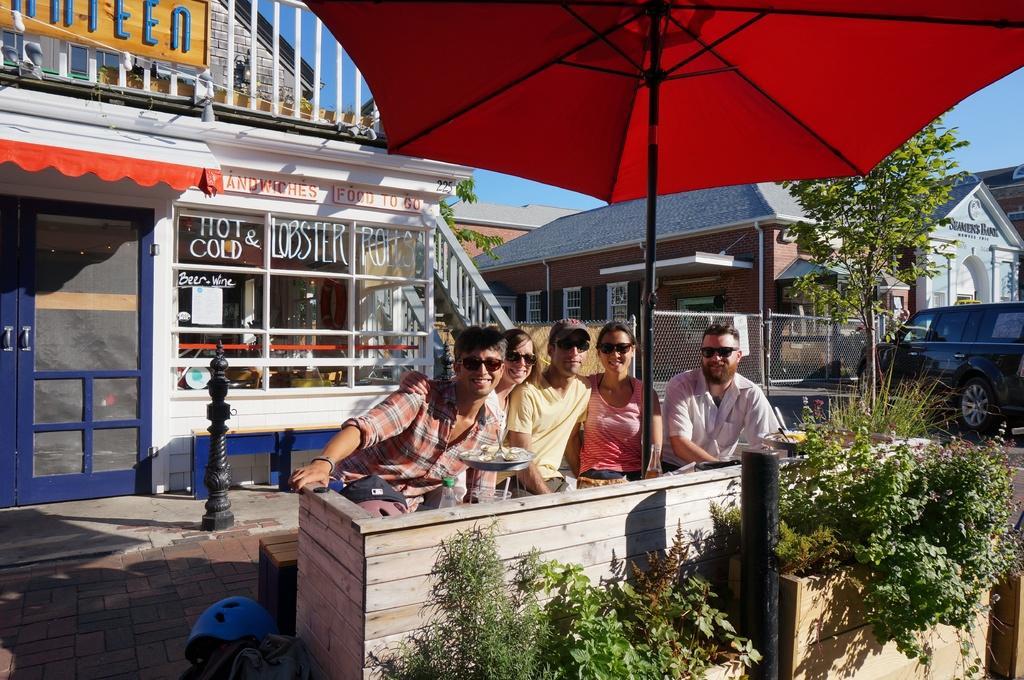Please provide a concise description of this image. In this image I can see five persons are sitting and I can see all of them are wearing black shades. I can also see few of them are smiling. In the front of the image I can see a pole, number of plants and a red colour umbrella. On the bottom left side of the image I can see a blue colour helmet and a bag. I can also see few things in the front of them. In the background I can see number of buildings, few trees, a vehicle, the sky, few boards and a rope on the top left side. I can also see something is written on these buildings and on the boards. 